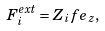Convert formula to latex. <formula><loc_0><loc_0><loc_500><loc_500>F _ { i } ^ { e x t } = Z _ { i } f e _ { z } ,</formula> 